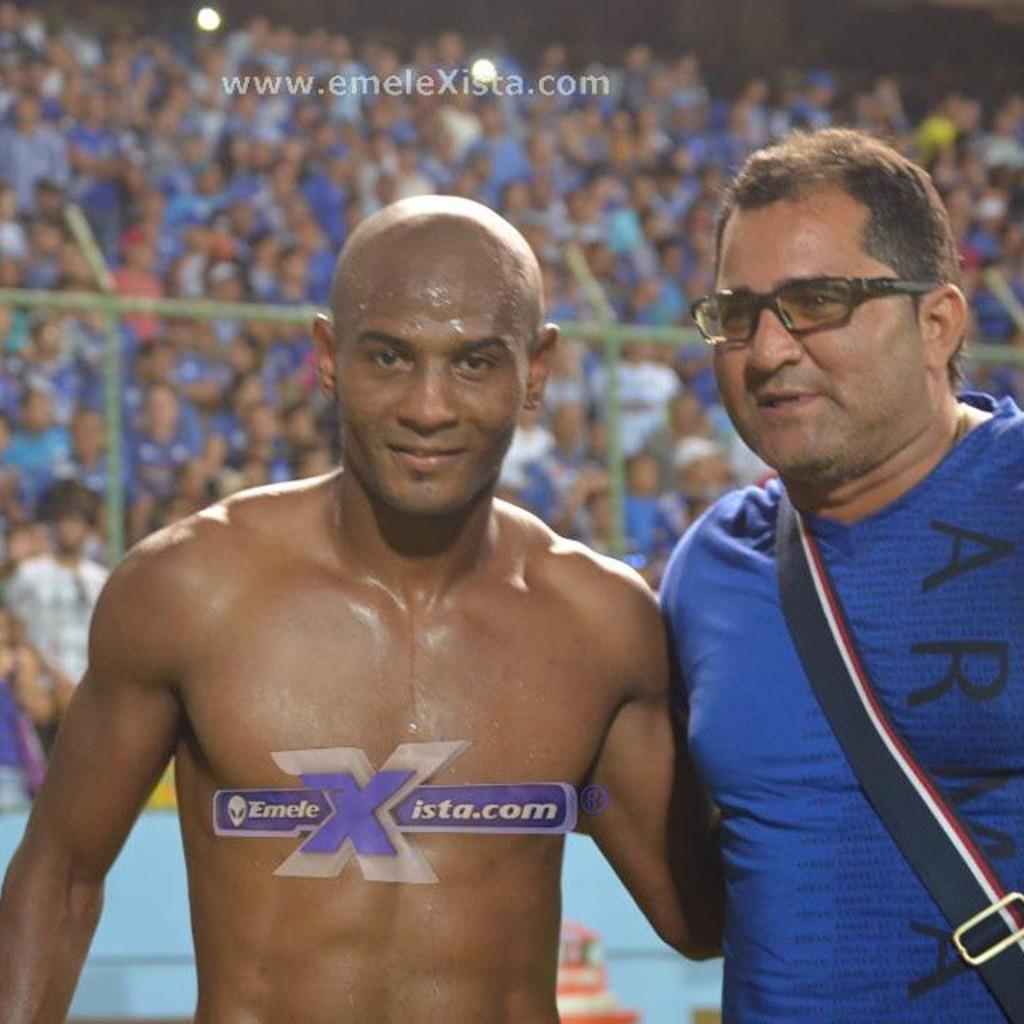What website is he sponsoring?
Provide a short and direct response. Emelexista.com. What are the first two letters on the man's shirt?
Your response must be concise. Ar. 